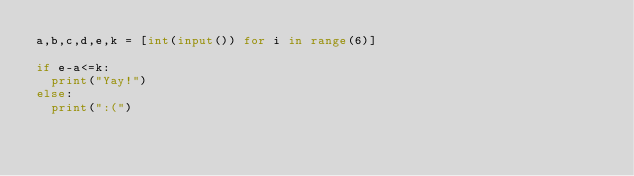<code> <loc_0><loc_0><loc_500><loc_500><_Python_>a,b,c,d,e,k = [int(input()) for i in range(6)]

if e-a<=k:
  print("Yay!")
else:
  print(":(")</code> 